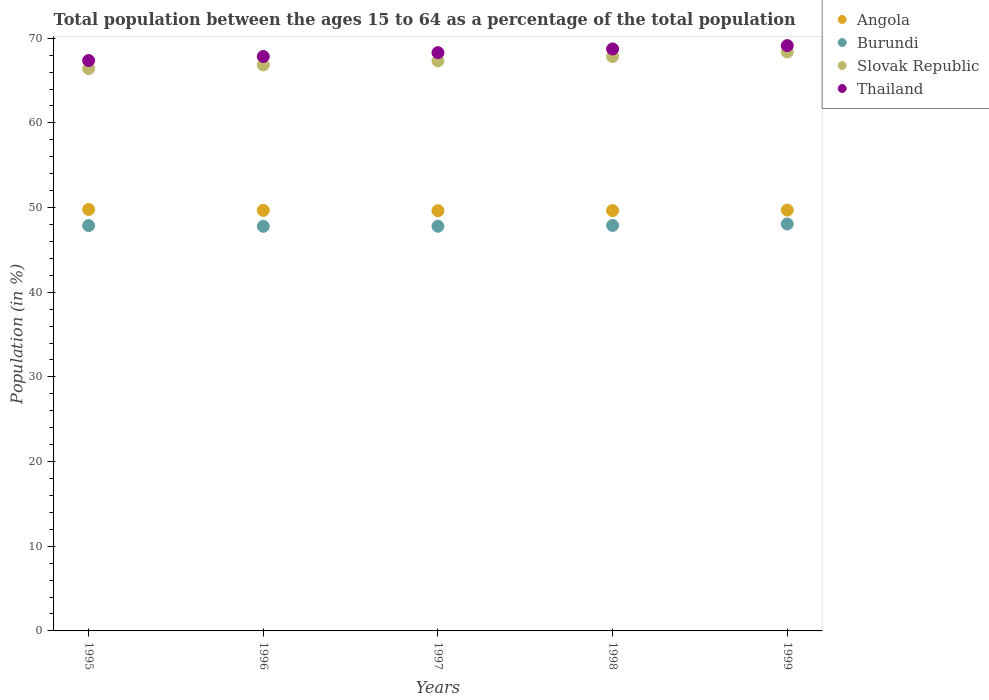How many different coloured dotlines are there?
Offer a very short reply. 4. What is the percentage of the population ages 15 to 64 in Angola in 1995?
Offer a very short reply. 49.78. Across all years, what is the maximum percentage of the population ages 15 to 64 in Burundi?
Offer a terse response. 48.06. Across all years, what is the minimum percentage of the population ages 15 to 64 in Angola?
Ensure brevity in your answer.  49.62. In which year was the percentage of the population ages 15 to 64 in Angola minimum?
Provide a short and direct response. 1997. What is the total percentage of the population ages 15 to 64 in Angola in the graph?
Your response must be concise. 248.41. What is the difference between the percentage of the population ages 15 to 64 in Burundi in 1997 and that in 1999?
Provide a short and direct response. -0.27. What is the difference between the percentage of the population ages 15 to 64 in Burundi in 1998 and the percentage of the population ages 15 to 64 in Angola in 1995?
Ensure brevity in your answer.  -1.89. What is the average percentage of the population ages 15 to 64 in Thailand per year?
Offer a terse response. 68.27. In the year 1996, what is the difference between the percentage of the population ages 15 to 64 in Angola and percentage of the population ages 15 to 64 in Slovak Republic?
Provide a succinct answer. -17.18. What is the ratio of the percentage of the population ages 15 to 64 in Angola in 1995 to that in 1998?
Provide a succinct answer. 1. Is the percentage of the population ages 15 to 64 in Angola in 1997 less than that in 1999?
Provide a short and direct response. Yes. What is the difference between the highest and the second highest percentage of the population ages 15 to 64 in Thailand?
Your answer should be compact. 0.4. What is the difference between the highest and the lowest percentage of the population ages 15 to 64 in Slovak Republic?
Your answer should be very brief. 1.97. Is the sum of the percentage of the population ages 15 to 64 in Angola in 1997 and 1999 greater than the maximum percentage of the population ages 15 to 64 in Thailand across all years?
Your response must be concise. Yes. Does the percentage of the population ages 15 to 64 in Slovak Republic monotonically increase over the years?
Provide a succinct answer. Yes. Is the percentage of the population ages 15 to 64 in Burundi strictly greater than the percentage of the population ages 15 to 64 in Slovak Republic over the years?
Your response must be concise. No. Is the percentage of the population ages 15 to 64 in Slovak Republic strictly less than the percentage of the population ages 15 to 64 in Angola over the years?
Offer a very short reply. No. How many dotlines are there?
Provide a succinct answer. 4. How many years are there in the graph?
Your answer should be very brief. 5. What is the difference between two consecutive major ticks on the Y-axis?
Provide a short and direct response. 10. Does the graph contain grids?
Keep it short and to the point. No. Where does the legend appear in the graph?
Your answer should be compact. Top right. What is the title of the graph?
Give a very brief answer. Total population between the ages 15 to 64 as a percentage of the total population. Does "Sweden" appear as one of the legend labels in the graph?
Ensure brevity in your answer.  No. What is the Population (in %) of Angola in 1995?
Your response must be concise. 49.78. What is the Population (in %) of Burundi in 1995?
Keep it short and to the point. 47.87. What is the Population (in %) in Slovak Republic in 1995?
Keep it short and to the point. 66.41. What is the Population (in %) of Thailand in 1995?
Offer a terse response. 67.36. What is the Population (in %) in Angola in 1996?
Offer a very short reply. 49.66. What is the Population (in %) in Burundi in 1996?
Your response must be concise. 47.78. What is the Population (in %) in Slovak Republic in 1996?
Ensure brevity in your answer.  66.85. What is the Population (in %) of Thailand in 1996?
Provide a short and direct response. 67.84. What is the Population (in %) in Angola in 1997?
Your answer should be very brief. 49.62. What is the Population (in %) in Burundi in 1997?
Your answer should be very brief. 47.79. What is the Population (in %) in Slovak Republic in 1997?
Your response must be concise. 67.32. What is the Population (in %) of Thailand in 1997?
Ensure brevity in your answer.  68.29. What is the Population (in %) in Angola in 1998?
Keep it short and to the point. 49.64. What is the Population (in %) in Burundi in 1998?
Provide a short and direct response. 47.89. What is the Population (in %) of Slovak Republic in 1998?
Ensure brevity in your answer.  67.83. What is the Population (in %) of Thailand in 1998?
Make the answer very short. 68.73. What is the Population (in %) of Angola in 1999?
Ensure brevity in your answer.  49.7. What is the Population (in %) in Burundi in 1999?
Offer a very short reply. 48.06. What is the Population (in %) in Slovak Republic in 1999?
Provide a succinct answer. 68.37. What is the Population (in %) of Thailand in 1999?
Provide a succinct answer. 69.13. Across all years, what is the maximum Population (in %) of Angola?
Your response must be concise. 49.78. Across all years, what is the maximum Population (in %) of Burundi?
Your answer should be compact. 48.06. Across all years, what is the maximum Population (in %) in Slovak Republic?
Give a very brief answer. 68.37. Across all years, what is the maximum Population (in %) in Thailand?
Make the answer very short. 69.13. Across all years, what is the minimum Population (in %) in Angola?
Give a very brief answer. 49.62. Across all years, what is the minimum Population (in %) of Burundi?
Your answer should be compact. 47.78. Across all years, what is the minimum Population (in %) in Slovak Republic?
Your response must be concise. 66.41. Across all years, what is the minimum Population (in %) of Thailand?
Provide a succinct answer. 67.36. What is the total Population (in %) in Angola in the graph?
Offer a very short reply. 248.41. What is the total Population (in %) in Burundi in the graph?
Your response must be concise. 239.4. What is the total Population (in %) of Slovak Republic in the graph?
Your answer should be compact. 336.79. What is the total Population (in %) of Thailand in the graph?
Provide a succinct answer. 341.35. What is the difference between the Population (in %) of Angola in 1995 and that in 1996?
Offer a terse response. 0.11. What is the difference between the Population (in %) of Burundi in 1995 and that in 1996?
Make the answer very short. 0.09. What is the difference between the Population (in %) in Slovak Republic in 1995 and that in 1996?
Offer a very short reply. -0.44. What is the difference between the Population (in %) in Thailand in 1995 and that in 1996?
Keep it short and to the point. -0.48. What is the difference between the Population (in %) of Angola in 1995 and that in 1997?
Make the answer very short. 0.15. What is the difference between the Population (in %) of Burundi in 1995 and that in 1997?
Your answer should be compact. 0.08. What is the difference between the Population (in %) of Slovak Republic in 1995 and that in 1997?
Your answer should be compact. -0.92. What is the difference between the Population (in %) of Thailand in 1995 and that in 1997?
Give a very brief answer. -0.93. What is the difference between the Population (in %) in Angola in 1995 and that in 1998?
Make the answer very short. 0.13. What is the difference between the Population (in %) in Burundi in 1995 and that in 1998?
Your answer should be compact. -0.02. What is the difference between the Population (in %) in Slovak Republic in 1995 and that in 1998?
Keep it short and to the point. -1.42. What is the difference between the Population (in %) of Thailand in 1995 and that in 1998?
Ensure brevity in your answer.  -1.37. What is the difference between the Population (in %) in Angola in 1995 and that in 1999?
Give a very brief answer. 0.08. What is the difference between the Population (in %) in Burundi in 1995 and that in 1999?
Your response must be concise. -0.19. What is the difference between the Population (in %) in Slovak Republic in 1995 and that in 1999?
Offer a very short reply. -1.97. What is the difference between the Population (in %) in Thailand in 1995 and that in 1999?
Your answer should be compact. -1.76. What is the difference between the Population (in %) in Angola in 1996 and that in 1997?
Provide a succinct answer. 0.04. What is the difference between the Population (in %) in Burundi in 1996 and that in 1997?
Your response must be concise. -0.01. What is the difference between the Population (in %) of Slovak Republic in 1996 and that in 1997?
Your answer should be compact. -0.48. What is the difference between the Population (in %) of Thailand in 1996 and that in 1997?
Offer a very short reply. -0.45. What is the difference between the Population (in %) in Angola in 1996 and that in 1998?
Give a very brief answer. 0.02. What is the difference between the Population (in %) of Burundi in 1996 and that in 1998?
Offer a terse response. -0.1. What is the difference between the Population (in %) of Slovak Republic in 1996 and that in 1998?
Offer a very short reply. -0.98. What is the difference between the Population (in %) of Thailand in 1996 and that in 1998?
Give a very brief answer. -0.89. What is the difference between the Population (in %) in Angola in 1996 and that in 1999?
Keep it short and to the point. -0.04. What is the difference between the Population (in %) of Burundi in 1996 and that in 1999?
Give a very brief answer. -0.28. What is the difference between the Population (in %) in Slovak Republic in 1996 and that in 1999?
Offer a terse response. -1.53. What is the difference between the Population (in %) in Thailand in 1996 and that in 1999?
Your answer should be compact. -1.29. What is the difference between the Population (in %) of Angola in 1997 and that in 1998?
Keep it short and to the point. -0.02. What is the difference between the Population (in %) in Burundi in 1997 and that in 1998?
Your answer should be compact. -0.1. What is the difference between the Population (in %) in Slovak Republic in 1997 and that in 1998?
Give a very brief answer. -0.51. What is the difference between the Population (in %) of Thailand in 1997 and that in 1998?
Ensure brevity in your answer.  -0.44. What is the difference between the Population (in %) of Angola in 1997 and that in 1999?
Provide a short and direct response. -0.08. What is the difference between the Population (in %) of Burundi in 1997 and that in 1999?
Give a very brief answer. -0.27. What is the difference between the Population (in %) of Slovak Republic in 1997 and that in 1999?
Provide a succinct answer. -1.05. What is the difference between the Population (in %) in Thailand in 1997 and that in 1999?
Give a very brief answer. -0.83. What is the difference between the Population (in %) of Angola in 1998 and that in 1999?
Your response must be concise. -0.06. What is the difference between the Population (in %) in Burundi in 1998 and that in 1999?
Your answer should be compact. -0.17. What is the difference between the Population (in %) of Slovak Republic in 1998 and that in 1999?
Your answer should be compact. -0.54. What is the difference between the Population (in %) of Thailand in 1998 and that in 1999?
Your response must be concise. -0.4. What is the difference between the Population (in %) in Angola in 1995 and the Population (in %) in Burundi in 1996?
Provide a short and direct response. 1.99. What is the difference between the Population (in %) of Angola in 1995 and the Population (in %) of Slovak Republic in 1996?
Provide a succinct answer. -17.07. What is the difference between the Population (in %) of Angola in 1995 and the Population (in %) of Thailand in 1996?
Offer a terse response. -18.06. What is the difference between the Population (in %) of Burundi in 1995 and the Population (in %) of Slovak Republic in 1996?
Your answer should be very brief. -18.98. What is the difference between the Population (in %) of Burundi in 1995 and the Population (in %) of Thailand in 1996?
Offer a terse response. -19.97. What is the difference between the Population (in %) of Slovak Republic in 1995 and the Population (in %) of Thailand in 1996?
Offer a very short reply. -1.43. What is the difference between the Population (in %) of Angola in 1995 and the Population (in %) of Burundi in 1997?
Provide a short and direct response. 1.98. What is the difference between the Population (in %) in Angola in 1995 and the Population (in %) in Slovak Republic in 1997?
Keep it short and to the point. -17.55. What is the difference between the Population (in %) in Angola in 1995 and the Population (in %) in Thailand in 1997?
Ensure brevity in your answer.  -18.52. What is the difference between the Population (in %) in Burundi in 1995 and the Population (in %) in Slovak Republic in 1997?
Your answer should be very brief. -19.45. What is the difference between the Population (in %) in Burundi in 1995 and the Population (in %) in Thailand in 1997?
Ensure brevity in your answer.  -20.42. What is the difference between the Population (in %) in Slovak Republic in 1995 and the Population (in %) in Thailand in 1997?
Your answer should be compact. -1.88. What is the difference between the Population (in %) of Angola in 1995 and the Population (in %) of Burundi in 1998?
Make the answer very short. 1.89. What is the difference between the Population (in %) in Angola in 1995 and the Population (in %) in Slovak Republic in 1998?
Provide a succinct answer. -18.06. What is the difference between the Population (in %) of Angola in 1995 and the Population (in %) of Thailand in 1998?
Give a very brief answer. -18.95. What is the difference between the Population (in %) of Burundi in 1995 and the Population (in %) of Slovak Republic in 1998?
Your answer should be very brief. -19.96. What is the difference between the Population (in %) of Burundi in 1995 and the Population (in %) of Thailand in 1998?
Provide a succinct answer. -20.86. What is the difference between the Population (in %) of Slovak Republic in 1995 and the Population (in %) of Thailand in 1998?
Offer a very short reply. -2.32. What is the difference between the Population (in %) of Angola in 1995 and the Population (in %) of Burundi in 1999?
Offer a terse response. 1.72. What is the difference between the Population (in %) of Angola in 1995 and the Population (in %) of Slovak Republic in 1999?
Your response must be concise. -18.6. What is the difference between the Population (in %) of Angola in 1995 and the Population (in %) of Thailand in 1999?
Offer a terse response. -19.35. What is the difference between the Population (in %) in Burundi in 1995 and the Population (in %) in Slovak Republic in 1999?
Keep it short and to the point. -20.5. What is the difference between the Population (in %) in Burundi in 1995 and the Population (in %) in Thailand in 1999?
Provide a succinct answer. -21.26. What is the difference between the Population (in %) in Slovak Republic in 1995 and the Population (in %) in Thailand in 1999?
Your response must be concise. -2.72. What is the difference between the Population (in %) of Angola in 1996 and the Population (in %) of Burundi in 1997?
Your answer should be compact. 1.87. What is the difference between the Population (in %) in Angola in 1996 and the Population (in %) in Slovak Republic in 1997?
Your response must be concise. -17.66. What is the difference between the Population (in %) in Angola in 1996 and the Population (in %) in Thailand in 1997?
Provide a short and direct response. -18.63. What is the difference between the Population (in %) of Burundi in 1996 and the Population (in %) of Slovak Republic in 1997?
Give a very brief answer. -19.54. What is the difference between the Population (in %) in Burundi in 1996 and the Population (in %) in Thailand in 1997?
Provide a succinct answer. -20.51. What is the difference between the Population (in %) in Slovak Republic in 1996 and the Population (in %) in Thailand in 1997?
Offer a terse response. -1.45. What is the difference between the Population (in %) in Angola in 1996 and the Population (in %) in Burundi in 1998?
Offer a terse response. 1.78. What is the difference between the Population (in %) in Angola in 1996 and the Population (in %) in Slovak Republic in 1998?
Give a very brief answer. -18.17. What is the difference between the Population (in %) in Angola in 1996 and the Population (in %) in Thailand in 1998?
Give a very brief answer. -19.07. What is the difference between the Population (in %) of Burundi in 1996 and the Population (in %) of Slovak Republic in 1998?
Your answer should be very brief. -20.05. What is the difference between the Population (in %) in Burundi in 1996 and the Population (in %) in Thailand in 1998?
Your response must be concise. -20.94. What is the difference between the Population (in %) of Slovak Republic in 1996 and the Population (in %) of Thailand in 1998?
Your response must be concise. -1.88. What is the difference between the Population (in %) in Angola in 1996 and the Population (in %) in Burundi in 1999?
Make the answer very short. 1.6. What is the difference between the Population (in %) in Angola in 1996 and the Population (in %) in Slovak Republic in 1999?
Ensure brevity in your answer.  -18.71. What is the difference between the Population (in %) in Angola in 1996 and the Population (in %) in Thailand in 1999?
Provide a succinct answer. -19.46. What is the difference between the Population (in %) in Burundi in 1996 and the Population (in %) in Slovak Republic in 1999?
Offer a very short reply. -20.59. What is the difference between the Population (in %) of Burundi in 1996 and the Population (in %) of Thailand in 1999?
Your answer should be very brief. -21.34. What is the difference between the Population (in %) of Slovak Republic in 1996 and the Population (in %) of Thailand in 1999?
Offer a very short reply. -2.28. What is the difference between the Population (in %) in Angola in 1997 and the Population (in %) in Burundi in 1998?
Provide a short and direct response. 1.74. What is the difference between the Population (in %) of Angola in 1997 and the Population (in %) of Slovak Republic in 1998?
Your answer should be compact. -18.21. What is the difference between the Population (in %) of Angola in 1997 and the Population (in %) of Thailand in 1998?
Offer a very short reply. -19.11. What is the difference between the Population (in %) of Burundi in 1997 and the Population (in %) of Slovak Republic in 1998?
Your answer should be very brief. -20.04. What is the difference between the Population (in %) in Burundi in 1997 and the Population (in %) in Thailand in 1998?
Your response must be concise. -20.94. What is the difference between the Population (in %) in Slovak Republic in 1997 and the Population (in %) in Thailand in 1998?
Offer a terse response. -1.41. What is the difference between the Population (in %) of Angola in 1997 and the Population (in %) of Burundi in 1999?
Ensure brevity in your answer.  1.56. What is the difference between the Population (in %) in Angola in 1997 and the Population (in %) in Slovak Republic in 1999?
Your response must be concise. -18.75. What is the difference between the Population (in %) of Angola in 1997 and the Population (in %) of Thailand in 1999?
Provide a succinct answer. -19.5. What is the difference between the Population (in %) in Burundi in 1997 and the Population (in %) in Slovak Republic in 1999?
Your answer should be compact. -20.58. What is the difference between the Population (in %) in Burundi in 1997 and the Population (in %) in Thailand in 1999?
Your answer should be compact. -21.33. What is the difference between the Population (in %) of Slovak Republic in 1997 and the Population (in %) of Thailand in 1999?
Make the answer very short. -1.8. What is the difference between the Population (in %) in Angola in 1998 and the Population (in %) in Burundi in 1999?
Provide a short and direct response. 1.58. What is the difference between the Population (in %) in Angola in 1998 and the Population (in %) in Slovak Republic in 1999?
Make the answer very short. -18.73. What is the difference between the Population (in %) in Angola in 1998 and the Population (in %) in Thailand in 1999?
Your answer should be very brief. -19.48. What is the difference between the Population (in %) in Burundi in 1998 and the Population (in %) in Slovak Republic in 1999?
Offer a very short reply. -20.49. What is the difference between the Population (in %) in Burundi in 1998 and the Population (in %) in Thailand in 1999?
Offer a terse response. -21.24. What is the difference between the Population (in %) in Slovak Republic in 1998 and the Population (in %) in Thailand in 1999?
Your answer should be very brief. -1.29. What is the average Population (in %) of Angola per year?
Give a very brief answer. 49.68. What is the average Population (in %) in Burundi per year?
Keep it short and to the point. 47.88. What is the average Population (in %) in Slovak Republic per year?
Make the answer very short. 67.36. What is the average Population (in %) in Thailand per year?
Your response must be concise. 68.27. In the year 1995, what is the difference between the Population (in %) of Angola and Population (in %) of Burundi?
Offer a terse response. 1.91. In the year 1995, what is the difference between the Population (in %) of Angola and Population (in %) of Slovak Republic?
Your answer should be compact. -16.63. In the year 1995, what is the difference between the Population (in %) of Angola and Population (in %) of Thailand?
Your answer should be very brief. -17.59. In the year 1995, what is the difference between the Population (in %) of Burundi and Population (in %) of Slovak Republic?
Provide a succinct answer. -18.54. In the year 1995, what is the difference between the Population (in %) of Burundi and Population (in %) of Thailand?
Your answer should be compact. -19.49. In the year 1995, what is the difference between the Population (in %) of Slovak Republic and Population (in %) of Thailand?
Provide a succinct answer. -0.96. In the year 1996, what is the difference between the Population (in %) in Angola and Population (in %) in Burundi?
Provide a short and direct response. 1.88. In the year 1996, what is the difference between the Population (in %) in Angola and Population (in %) in Slovak Republic?
Provide a succinct answer. -17.18. In the year 1996, what is the difference between the Population (in %) of Angola and Population (in %) of Thailand?
Your response must be concise. -18.18. In the year 1996, what is the difference between the Population (in %) in Burundi and Population (in %) in Slovak Republic?
Your answer should be very brief. -19.06. In the year 1996, what is the difference between the Population (in %) of Burundi and Population (in %) of Thailand?
Ensure brevity in your answer.  -20.05. In the year 1996, what is the difference between the Population (in %) in Slovak Republic and Population (in %) in Thailand?
Keep it short and to the point. -0.99. In the year 1997, what is the difference between the Population (in %) in Angola and Population (in %) in Burundi?
Offer a very short reply. 1.83. In the year 1997, what is the difference between the Population (in %) of Angola and Population (in %) of Slovak Republic?
Your answer should be very brief. -17.7. In the year 1997, what is the difference between the Population (in %) in Angola and Population (in %) in Thailand?
Offer a terse response. -18.67. In the year 1997, what is the difference between the Population (in %) in Burundi and Population (in %) in Slovak Republic?
Your answer should be compact. -19.53. In the year 1997, what is the difference between the Population (in %) in Burundi and Population (in %) in Thailand?
Your answer should be compact. -20.5. In the year 1997, what is the difference between the Population (in %) of Slovak Republic and Population (in %) of Thailand?
Offer a terse response. -0.97. In the year 1998, what is the difference between the Population (in %) in Angola and Population (in %) in Burundi?
Keep it short and to the point. 1.76. In the year 1998, what is the difference between the Population (in %) in Angola and Population (in %) in Slovak Republic?
Provide a short and direct response. -18.19. In the year 1998, what is the difference between the Population (in %) of Angola and Population (in %) of Thailand?
Give a very brief answer. -19.09. In the year 1998, what is the difference between the Population (in %) in Burundi and Population (in %) in Slovak Republic?
Ensure brevity in your answer.  -19.94. In the year 1998, what is the difference between the Population (in %) of Burundi and Population (in %) of Thailand?
Provide a short and direct response. -20.84. In the year 1998, what is the difference between the Population (in %) in Slovak Republic and Population (in %) in Thailand?
Your answer should be compact. -0.9. In the year 1999, what is the difference between the Population (in %) in Angola and Population (in %) in Burundi?
Provide a short and direct response. 1.64. In the year 1999, what is the difference between the Population (in %) of Angola and Population (in %) of Slovak Republic?
Provide a short and direct response. -18.67. In the year 1999, what is the difference between the Population (in %) of Angola and Population (in %) of Thailand?
Give a very brief answer. -19.43. In the year 1999, what is the difference between the Population (in %) of Burundi and Population (in %) of Slovak Republic?
Give a very brief answer. -20.31. In the year 1999, what is the difference between the Population (in %) of Burundi and Population (in %) of Thailand?
Your answer should be compact. -21.07. In the year 1999, what is the difference between the Population (in %) of Slovak Republic and Population (in %) of Thailand?
Offer a very short reply. -0.75. What is the ratio of the Population (in %) in Angola in 1995 to that in 1996?
Provide a succinct answer. 1. What is the ratio of the Population (in %) of Slovak Republic in 1995 to that in 1996?
Offer a terse response. 0.99. What is the ratio of the Population (in %) in Burundi in 1995 to that in 1997?
Give a very brief answer. 1. What is the ratio of the Population (in %) of Slovak Republic in 1995 to that in 1997?
Give a very brief answer. 0.99. What is the ratio of the Population (in %) of Thailand in 1995 to that in 1997?
Your response must be concise. 0.99. What is the ratio of the Population (in %) in Angola in 1995 to that in 1998?
Give a very brief answer. 1. What is the ratio of the Population (in %) in Thailand in 1995 to that in 1998?
Your response must be concise. 0.98. What is the ratio of the Population (in %) of Burundi in 1995 to that in 1999?
Your answer should be compact. 1. What is the ratio of the Population (in %) of Slovak Republic in 1995 to that in 1999?
Give a very brief answer. 0.97. What is the ratio of the Population (in %) of Thailand in 1995 to that in 1999?
Provide a succinct answer. 0.97. What is the ratio of the Population (in %) of Burundi in 1996 to that in 1997?
Provide a succinct answer. 1. What is the ratio of the Population (in %) of Slovak Republic in 1996 to that in 1997?
Make the answer very short. 0.99. What is the ratio of the Population (in %) in Thailand in 1996 to that in 1997?
Your answer should be compact. 0.99. What is the ratio of the Population (in %) of Angola in 1996 to that in 1998?
Offer a very short reply. 1. What is the ratio of the Population (in %) in Burundi in 1996 to that in 1998?
Offer a terse response. 1. What is the ratio of the Population (in %) in Slovak Republic in 1996 to that in 1998?
Your answer should be very brief. 0.99. What is the ratio of the Population (in %) of Thailand in 1996 to that in 1998?
Provide a succinct answer. 0.99. What is the ratio of the Population (in %) of Angola in 1996 to that in 1999?
Provide a short and direct response. 1. What is the ratio of the Population (in %) in Burundi in 1996 to that in 1999?
Ensure brevity in your answer.  0.99. What is the ratio of the Population (in %) in Slovak Republic in 1996 to that in 1999?
Your answer should be very brief. 0.98. What is the ratio of the Population (in %) of Thailand in 1996 to that in 1999?
Offer a terse response. 0.98. What is the ratio of the Population (in %) in Angola in 1997 to that in 1998?
Make the answer very short. 1. What is the ratio of the Population (in %) in Burundi in 1997 to that in 1999?
Offer a terse response. 0.99. What is the ratio of the Population (in %) of Slovak Republic in 1997 to that in 1999?
Give a very brief answer. 0.98. What is the ratio of the Population (in %) in Thailand in 1997 to that in 1999?
Your answer should be compact. 0.99. What is the ratio of the Population (in %) of Angola in 1998 to that in 1999?
Your response must be concise. 1. What is the ratio of the Population (in %) of Burundi in 1998 to that in 1999?
Your answer should be very brief. 1. What is the difference between the highest and the second highest Population (in %) in Angola?
Your answer should be compact. 0.08. What is the difference between the highest and the second highest Population (in %) of Burundi?
Keep it short and to the point. 0.17. What is the difference between the highest and the second highest Population (in %) in Slovak Republic?
Provide a short and direct response. 0.54. What is the difference between the highest and the second highest Population (in %) of Thailand?
Offer a terse response. 0.4. What is the difference between the highest and the lowest Population (in %) in Angola?
Give a very brief answer. 0.15. What is the difference between the highest and the lowest Population (in %) of Burundi?
Offer a very short reply. 0.28. What is the difference between the highest and the lowest Population (in %) in Slovak Republic?
Make the answer very short. 1.97. What is the difference between the highest and the lowest Population (in %) in Thailand?
Provide a succinct answer. 1.76. 